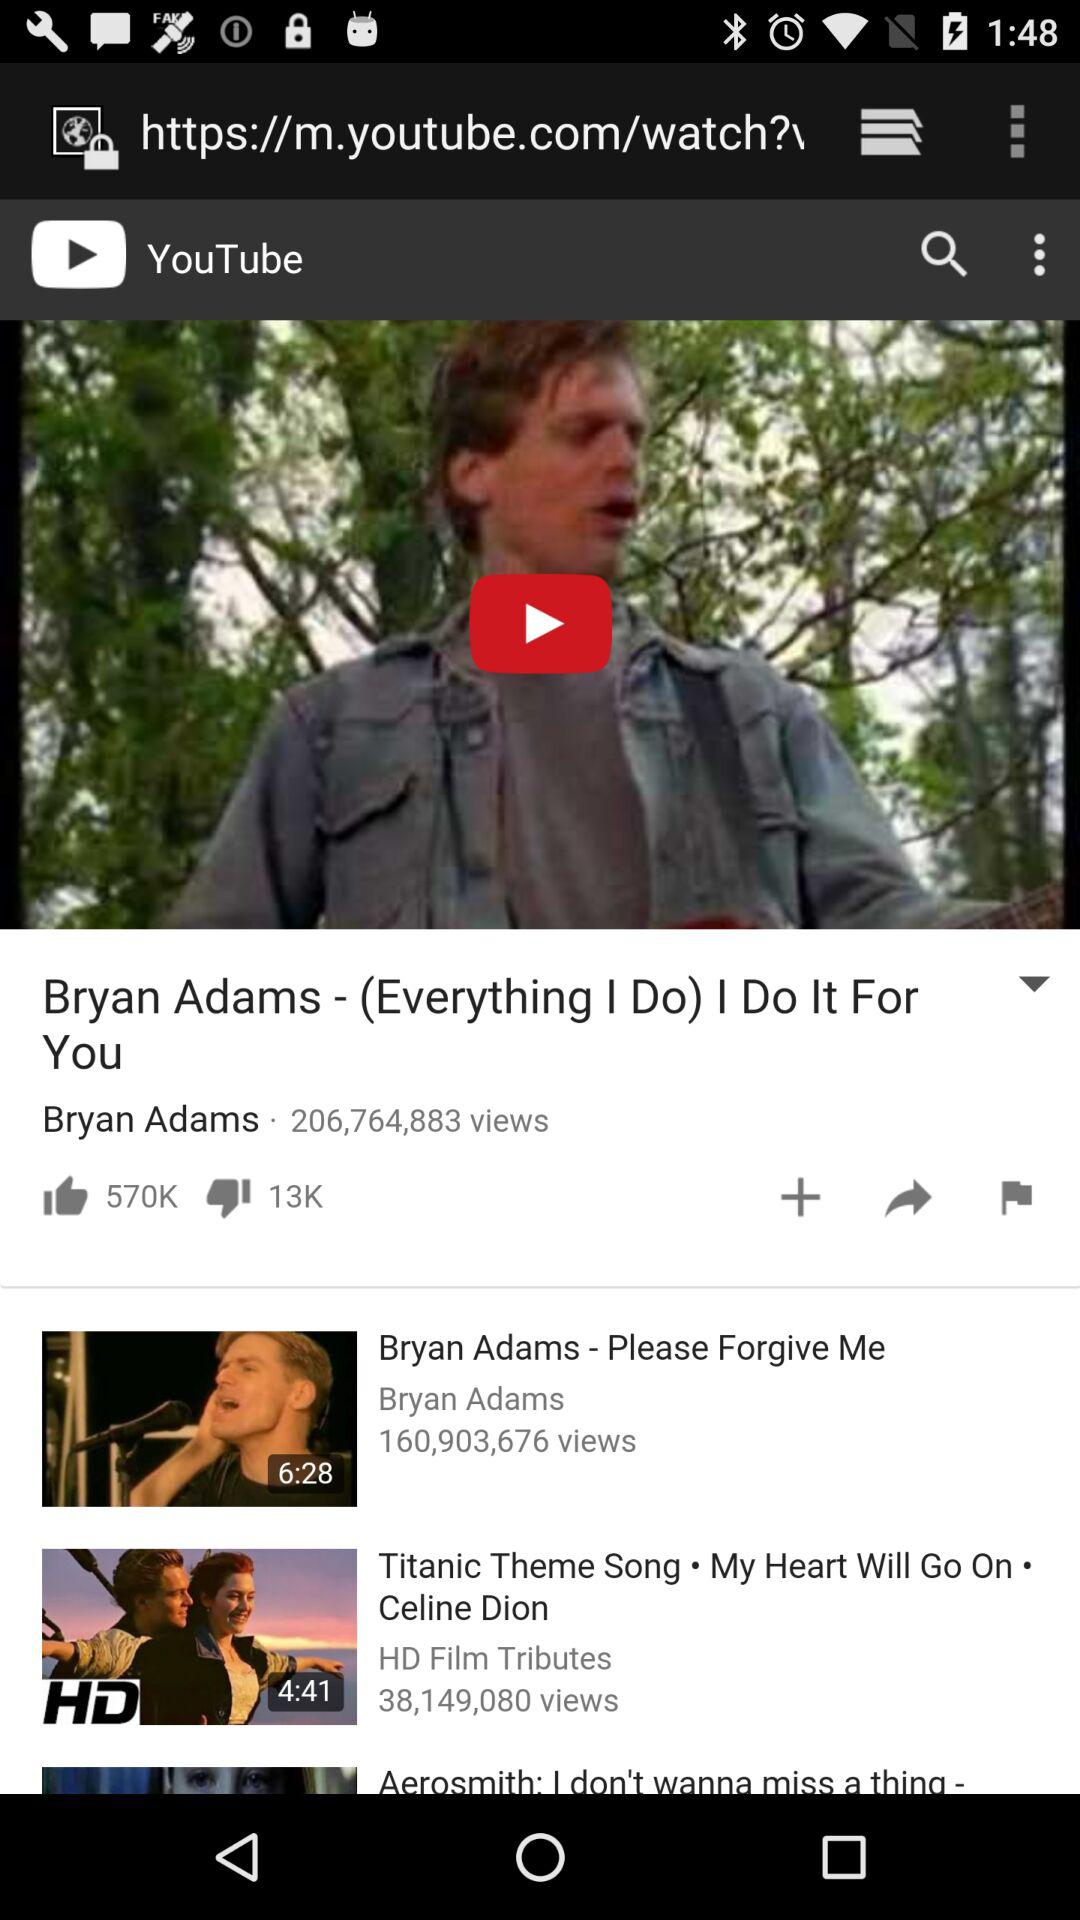How many people have disliked the video? The video has been disliked by 13,000 people. 